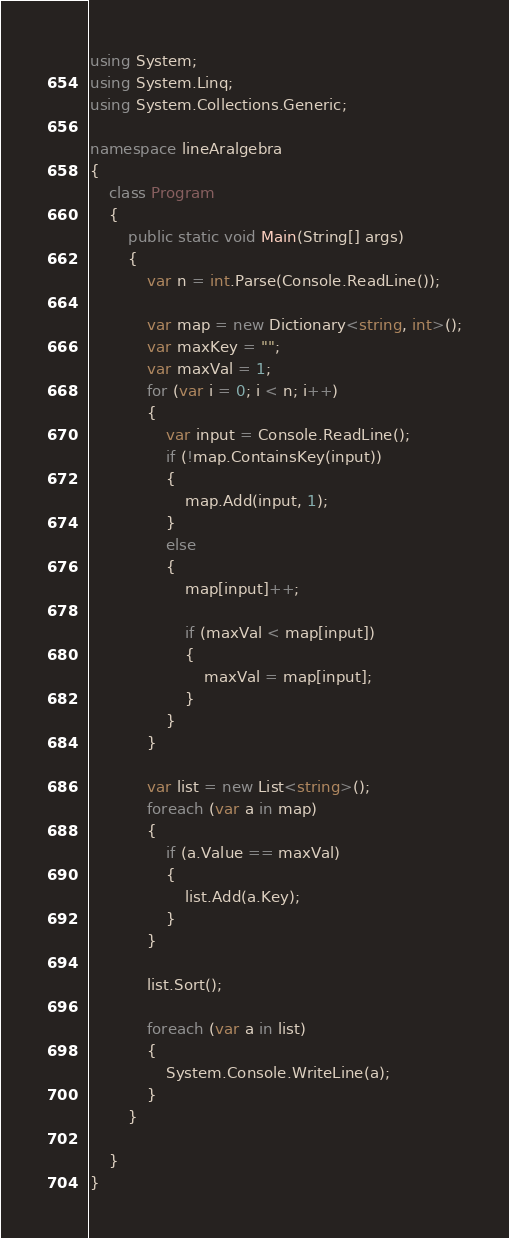Convert code to text. <code><loc_0><loc_0><loc_500><loc_500><_C#_>using System;
using System.Linq;
using System.Collections.Generic;

namespace lineAralgebra
{
	class Program
	{
		public static void Main(String[] args)
		{
			var n = int.Parse(Console.ReadLine());

			var map = new Dictionary<string, int>();
			var maxKey = "";
			var maxVal = 1;
			for (var i = 0; i < n; i++)
			{
				var input = Console.ReadLine();
				if (!map.ContainsKey(input))
				{
					map.Add(input, 1);
				}
				else
				{
					map[input]++;

					if (maxVal < map[input])
					{
						maxVal = map[input];
					}
				}
			}

			var list = new List<string>();
			foreach (var a in map)
			{
				if (a.Value == maxVal)
				{
					list.Add(a.Key);
				}
			}

			list.Sort();

			foreach (var a in list)
			{
				System.Console.WriteLine(a);
			}
		}

	}
}

</code> 